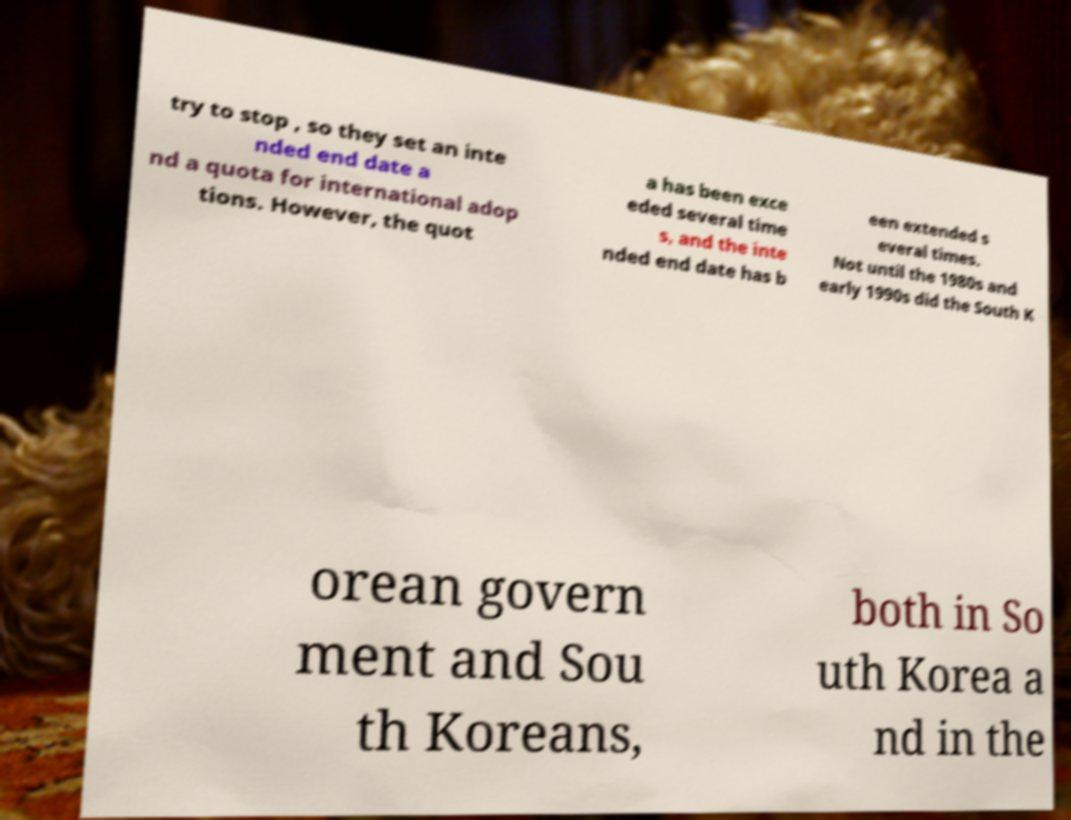What messages or text are displayed in this image? I need them in a readable, typed format. try to stop , so they set an inte nded end date a nd a quota for international adop tions. However, the quot a has been exce eded several time s, and the inte nded end date has b een extended s everal times. Not until the 1980s and early 1990s did the South K orean govern ment and Sou th Koreans, both in So uth Korea a nd in the 